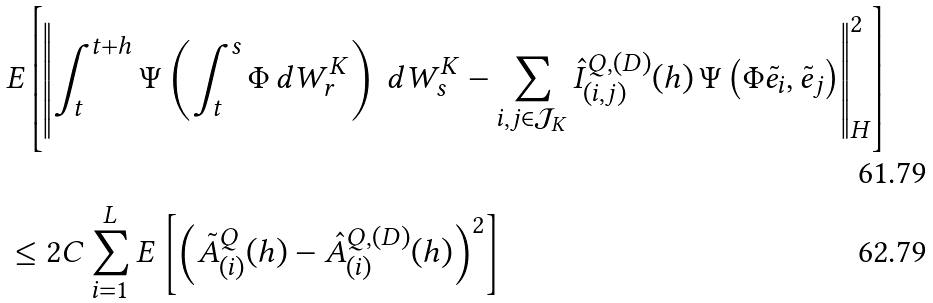Convert formula to latex. <formula><loc_0><loc_0><loc_500><loc_500>& E \left [ \left \| \int _ { t } ^ { t + h } \Psi \left ( \int _ { t } ^ { s } \Phi \, d W _ { r } ^ { K } \right ) \, d W _ { s } ^ { K } - \sum _ { i , j \in \mathcal { J } _ { K } } \hat { I } _ { ( i , j ) } ^ { Q , ( D ) } ( h ) \, \Psi \left ( \Phi \tilde { e } _ { i } , \tilde { e } _ { j } \right ) \right \| _ { H } ^ { 2 } \right ] \\ & \leq 2 C \sum _ { i = 1 } ^ { L } E \left [ \left ( \tilde { A } _ { ( i ) } ^ { Q } ( h ) - \hat { A } _ { ( i ) } ^ { Q , ( D ) } ( h ) \right ) ^ { 2 } \right ]</formula> 